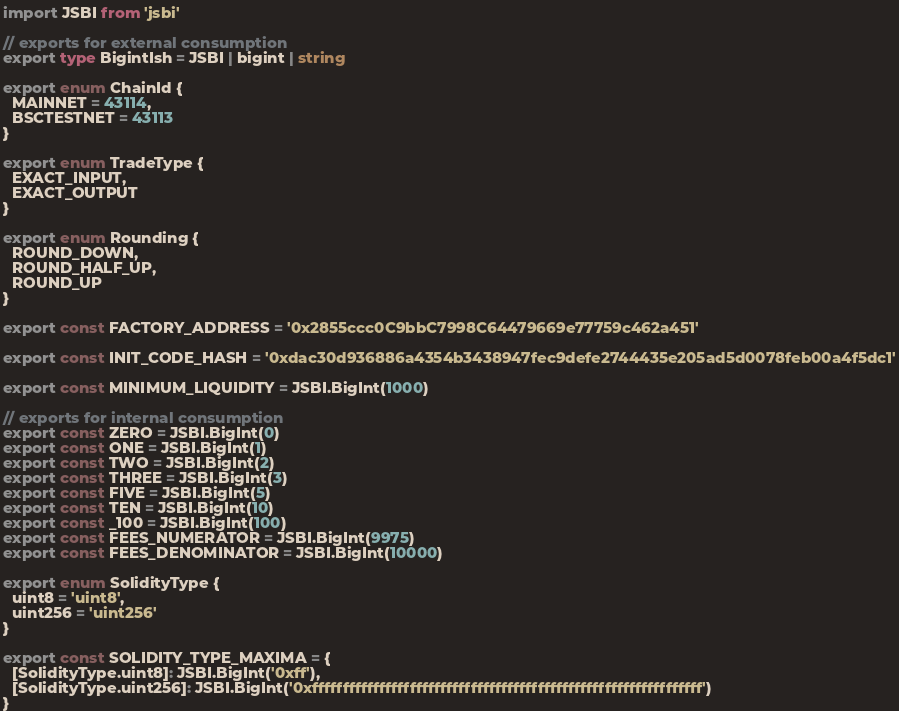<code> <loc_0><loc_0><loc_500><loc_500><_TypeScript_>import JSBI from 'jsbi'

// exports for external consumption
export type BigintIsh = JSBI | bigint | string

export enum ChainId {
  MAINNET = 43114,
  BSCTESTNET = 43113
}

export enum TradeType {
  EXACT_INPUT,
  EXACT_OUTPUT
}

export enum Rounding {
  ROUND_DOWN,
  ROUND_HALF_UP,
  ROUND_UP
}

export const FACTORY_ADDRESS = '0x2855ccc0C9bbC7998C64479669e77759c462a451'

export const INIT_CODE_HASH = '0xdac30d936886a4354b3438947fec9defe2744435e205ad5d0078feb00a4f5dc1'

export const MINIMUM_LIQUIDITY = JSBI.BigInt(1000)

// exports for internal consumption
export const ZERO = JSBI.BigInt(0)
export const ONE = JSBI.BigInt(1)
export const TWO = JSBI.BigInt(2)
export const THREE = JSBI.BigInt(3)
export const FIVE = JSBI.BigInt(5)
export const TEN = JSBI.BigInt(10)
export const _100 = JSBI.BigInt(100)
export const FEES_NUMERATOR = JSBI.BigInt(9975)
export const FEES_DENOMINATOR = JSBI.BigInt(10000)

export enum SolidityType {
  uint8 = 'uint8',
  uint256 = 'uint256'
}

export const SOLIDITY_TYPE_MAXIMA = {
  [SolidityType.uint8]: JSBI.BigInt('0xff'),
  [SolidityType.uint256]: JSBI.BigInt('0xffffffffffffffffffffffffffffffffffffffffffffffffffffffffffffffff')
}
</code> 